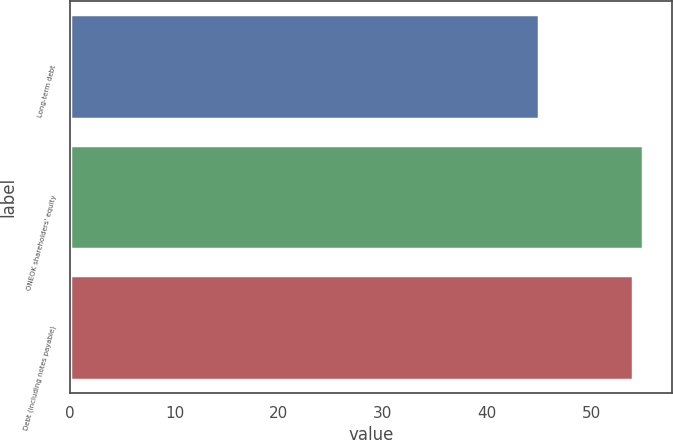Convert chart to OTSL. <chart><loc_0><loc_0><loc_500><loc_500><bar_chart><fcel>Long-term debt<fcel>ONEOK shareholders' equity<fcel>Debt (including notes payable)<nl><fcel>45<fcel>55<fcel>54<nl></chart> 